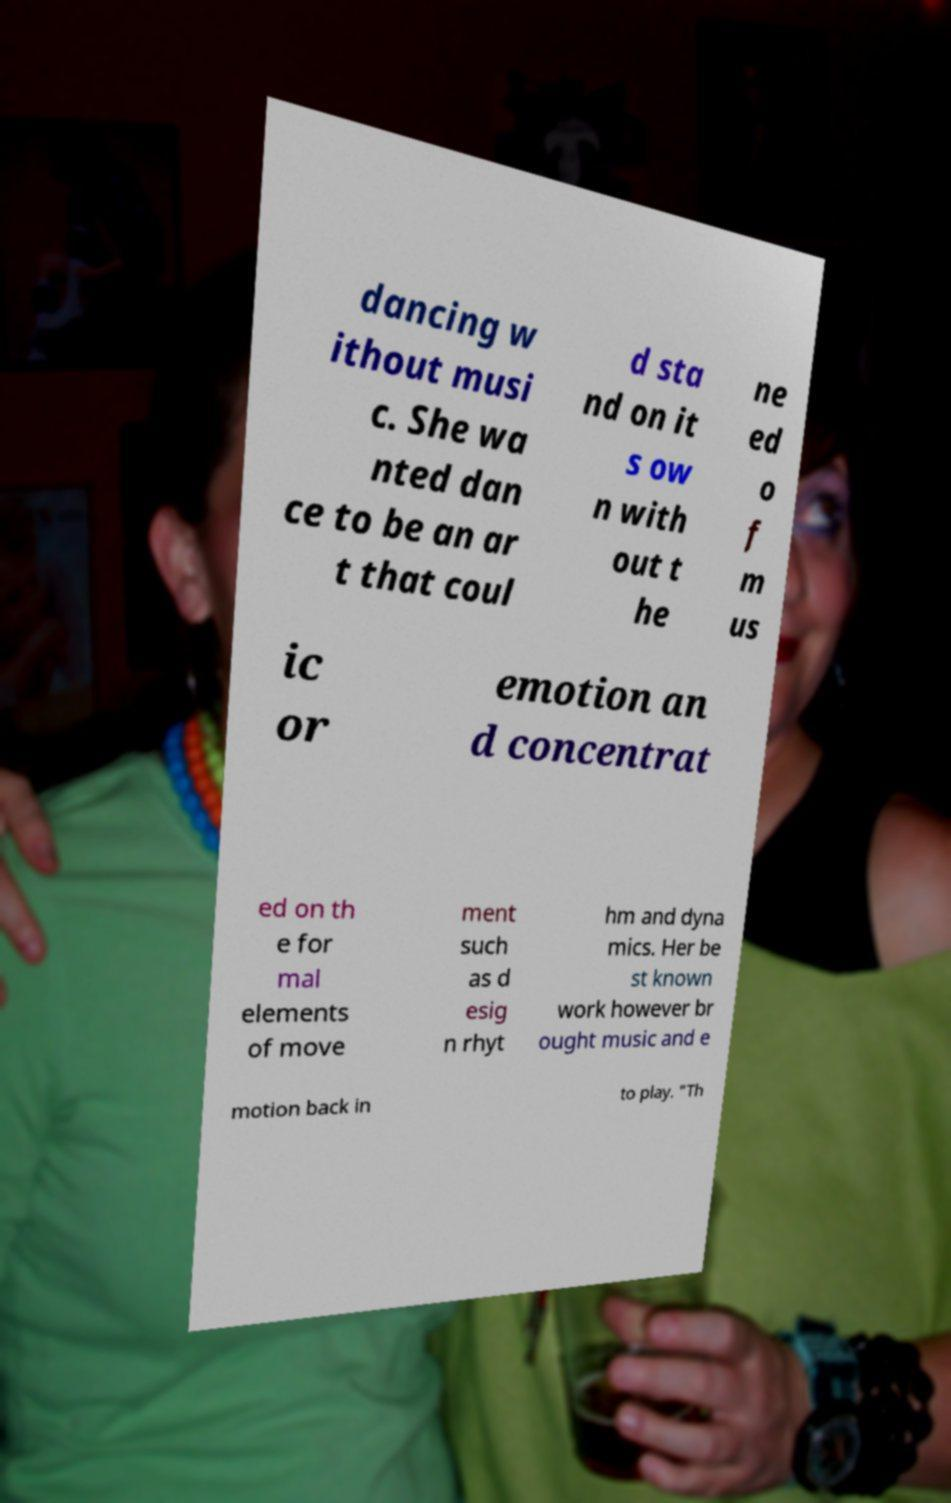What messages or text are displayed in this image? I need them in a readable, typed format. dancing w ithout musi c. She wa nted dan ce to be an ar t that coul d sta nd on it s ow n with out t he ne ed o f m us ic or emotion an d concentrat ed on th e for mal elements of move ment such as d esig n rhyt hm and dyna mics. Her be st known work however br ought music and e motion back in to play. "Th 